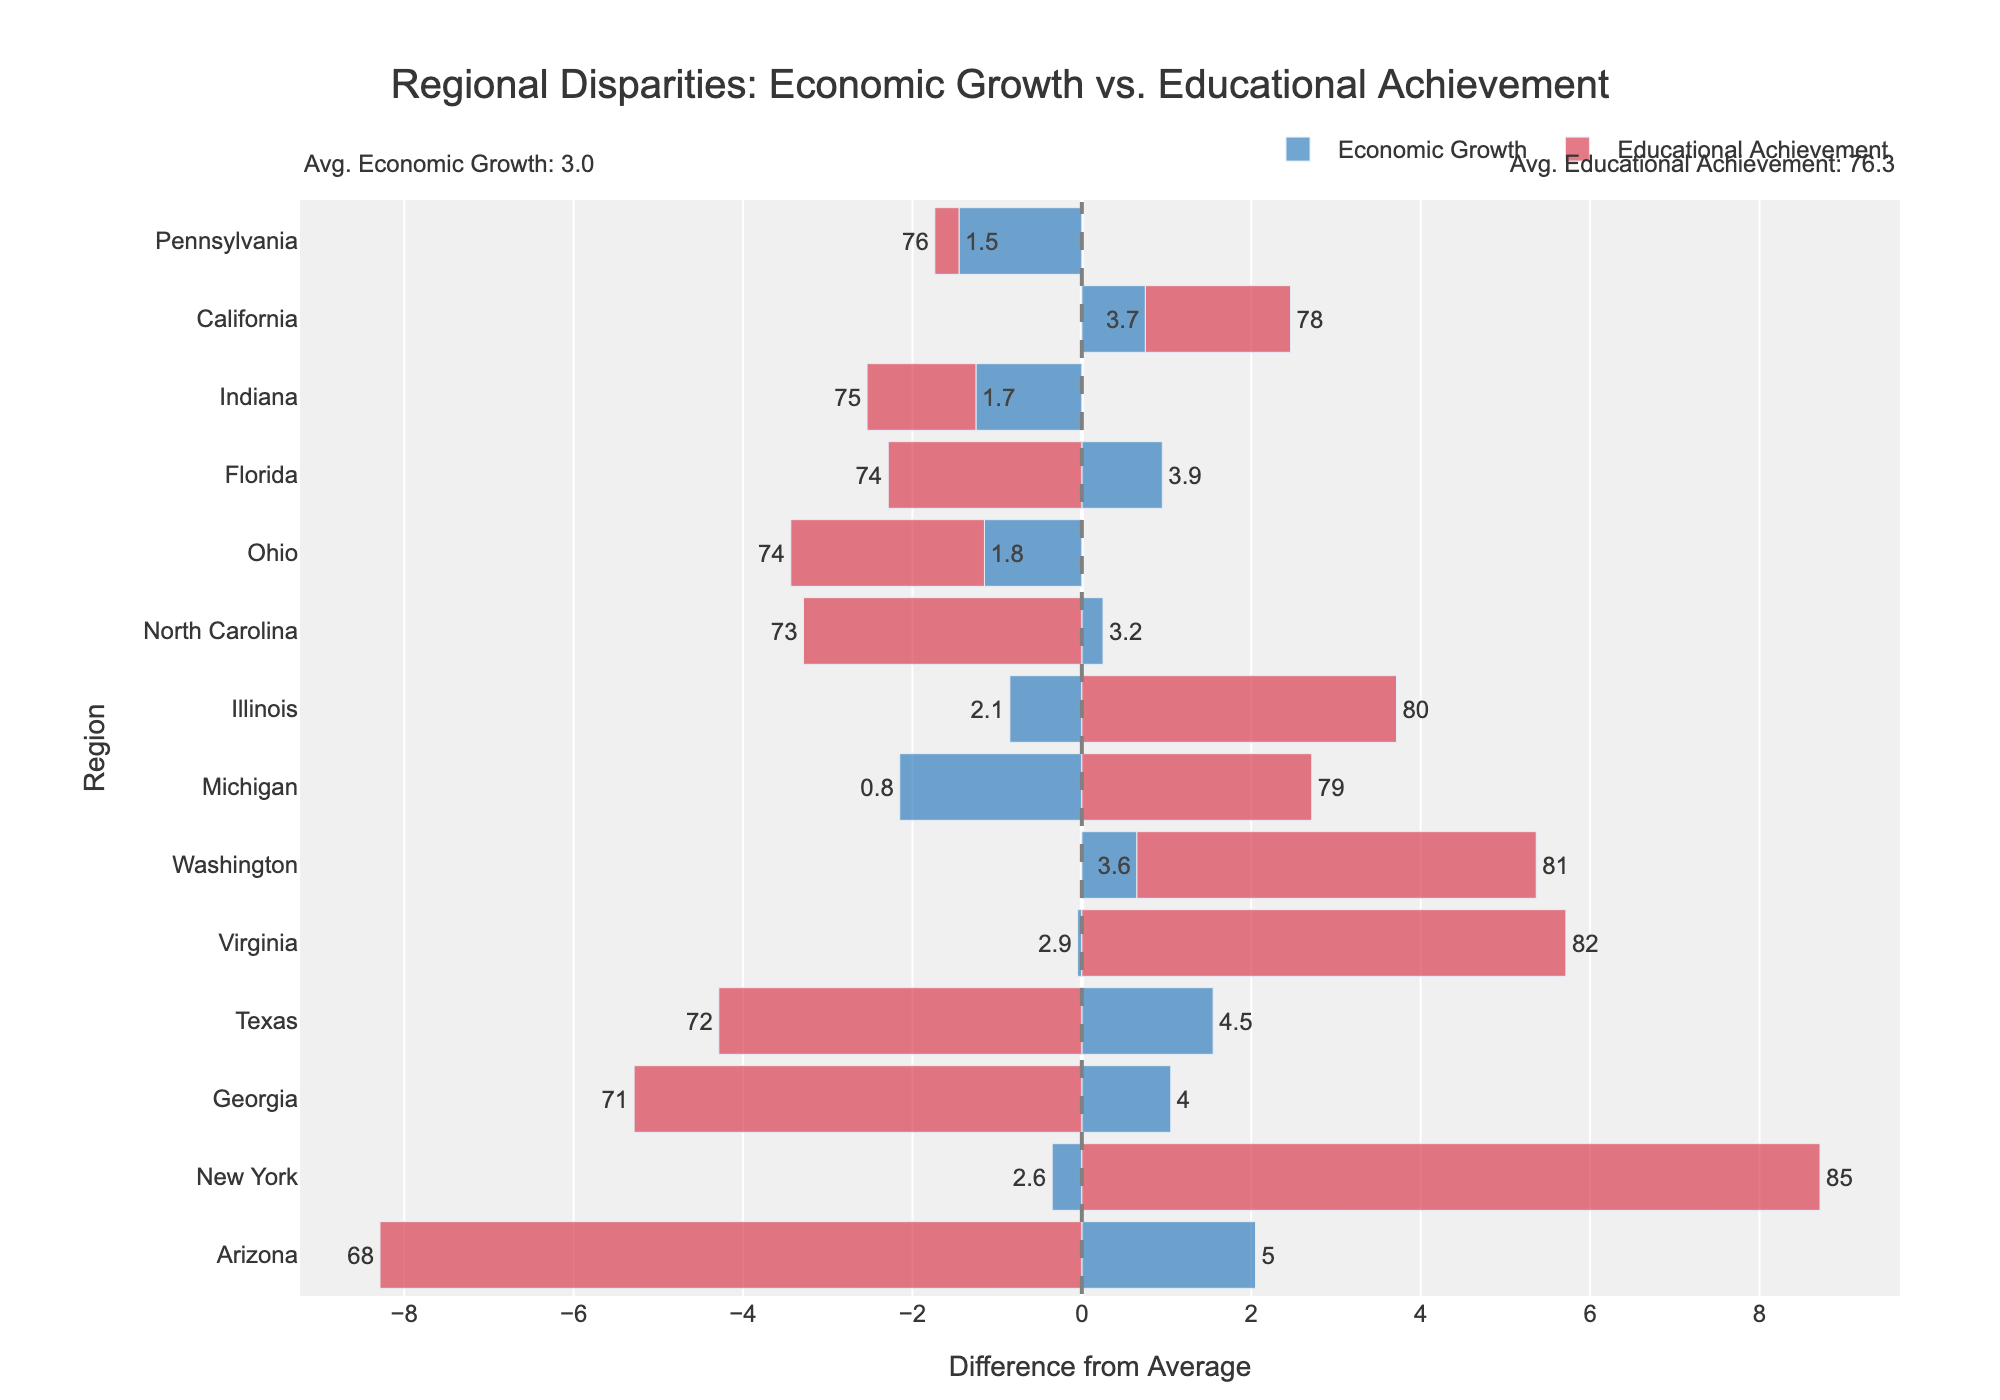Which region has the highest economic growth difference from the average? The Economic_diff for each region can be visualized by the length of the blue bars on the figure. The longest blue bar represents the largest positive deviation from the average.
Answer: Arizona Which region has the lowest educational achievement difference from the average? The Educational_diff for each region can be visualized by the length of the red bars on the figure. The longest negative red bar represents the largest negative deviation from the average.
Answer: Arizona Which regions have both economic growth and educational achievement above the average? Regions with both positive Economic_diff (blue bar to the right of the 0 line) and positive Educational_diff (red bar to the right of the 0 line) can be identified by visually scanning the chart.
Answer: New York, Virginia, Washington How does the economic growth difference compare between Texas and Illinois? Evaluate the position and length of the blue bars for Texas and Illinois relative to the x=0 line. Texas has a positive difference while Illinois has a negative difference.
Answer: Texas has a higher economic growth difference than Illinois What is the total difference (sum of absolute economic and educational differences) for Ohio? Find the Economic_diff and Educational_diff for Ohio by locating the blue and red bars associated with Ohio. Sum the absolute values of these differences.
Answer: 1.9 (1.8 + 0.1) Which region has nearly the same difference in educational achievement as in economic growth? Identify regions where the lengths of the blue and red bars are approximately equal.
Answer: Pennsylvania (both bars are close in length) Among the regions with above-average economic growth, which one has the lowest educational achievement? Look for regions with longer blue bars to the right of the 0 line (positive Economic_diff) and find the one with the shortest or most negative red bar.
Answer: Texas What is the combined difference (economic and educational) for Florida and Michigan? For Florida: Sum the absolute Economic_diff and Educational_diff; For Michigan: Sum the absolute values; Then sum these results.
Answer: 7.5 (Florida: 1.2 + 4.2 + Michigan: 2.6 + 1.6) Which region has the most balanced economic and educational achievement as compared to the average? The most balanced region would have blue and red bars closest to the same length (smallest total_diff).
Answer: Pennsylvania If you rank regions by their educational achievement difference, which regions fall at the top and bottom of the list? Identify regions with the longest red bars, both positive and negative. The top region will have the longest positive red bar and the bottom will have the longest negative.
Answer: Top: New York; Bottom: Arizona 